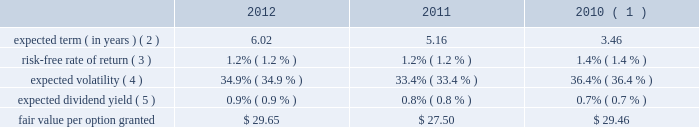Visa inc .
Notes to consolidated financial statements 2014 ( continued ) september 30 , 2012 acquired by the company .
The eip will continue to be in effect until all of the common stock available under the eip is delivered and all restrictions on those shares have lapsed , unless the eip is terminated earlier by the company 2019s board of directors .
No awards may be granted under the plan on or after 10 years from its effective date .
Share-based compensation cost is recorded net of estimated forfeitures on a straight-line basis for awards with service conditions only , and on a graded-vesting basis for awards with service , performance and market conditions .
The company 2019s estimated forfeiture rate is based on an evaluation of historical , actual and trended forfeiture data .
For fiscal 2012 , 2011 , and 2010 , the company recorded share-based compensation cost of $ 147 million , $ 154 million and $ 135 million , respectively , in personnel on its consolidated statements of operations .
The amount of capitalized share-based compensation cost was immaterial during fiscal 2012 , 2011 , and 2010 .
Options options issued under the eip expire 10 years from the date of grant and vest ratably over three years from the date of grant , subject to earlier vesting in full under certain conditions .
During fiscal 2012 , 2011 and 2010 , the fair value of each stock option was estimated on the date of grant using a black-scholes option pricing model with the following weighted-average assumptions : 2012 2011 2010 ( 1 ) expected term ( in years ) ( 2 ) .
6.02 5.16 3.46 risk-free rate of return ( 3 ) .
1.2% ( 1.2 % ) 1.2% ( 1.2 % ) 1.4% ( 1.4 % ) expected volatility ( 4 ) .
34.9% ( 34.9 % ) 33.4% ( 33.4 % ) 36.4% ( 36.4 % ) expected dividend yield ( 5 ) .
0.9% ( 0.9 % ) 0.8% ( 0.8 % ) 0.7% ( 0.7 % ) .
( 1 ) includes the impact of 1.6 million replacement awards issued to former cybersource employees as part of the cybersource acquisition in july 2010 .
These awards have a weighted-average exercise price of $ 47.34 per share and vest over a period of less than three years from the replacement grant date .
( 2 ) based on a set of peer companies that management believes is generally comparable to visa .
( 3 ) based upon the zero coupon u.s .
Treasury bond rate over the expected term of the awards .
( 4 ) based on the average of the company 2019s implied and historical volatility .
As the company 2019s publicly traded stock history is relatively short , historical volatility relies in part on the historical volatility of a group of peer companies that management believes is generally comparable to visa .
The expected volatilities ranged from 31% ( 31 % ) to 35% ( 35 % ) in fiscal 2012 .
( 5 ) based on the company 2019s annual dividend rate on the date of grant. .
What is the expected dividend per share for former cybersource employees in 2010? 
Computations: (47.34 * 0.7%)
Answer: 0.33138. 